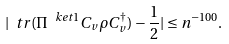<formula> <loc_0><loc_0><loc_500><loc_500>| \ t r ( \Pi ^ { \ k e t { 1 } } C _ { v } \rho C _ { v } ^ { \dag } ) - \frac { 1 } { 2 } | \leq n ^ { - 1 0 0 } .</formula> 